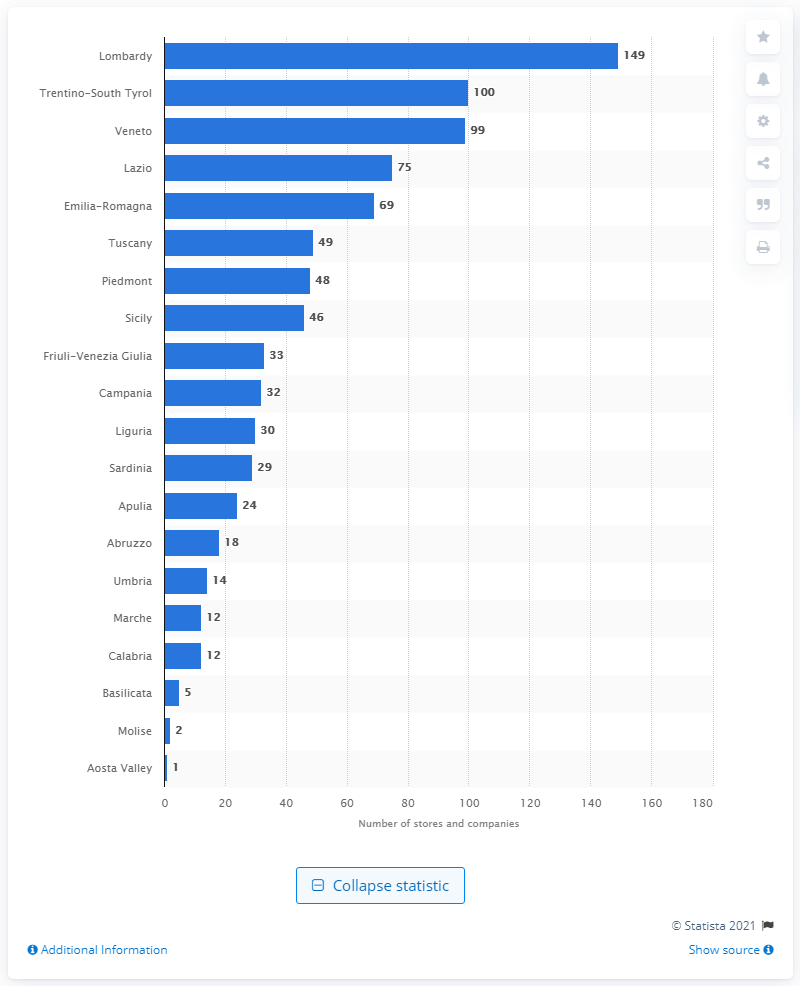Outline some significant characteristics in this image. There are 100 stores in Trentino-South Tyrol that accept Bitcoin. 